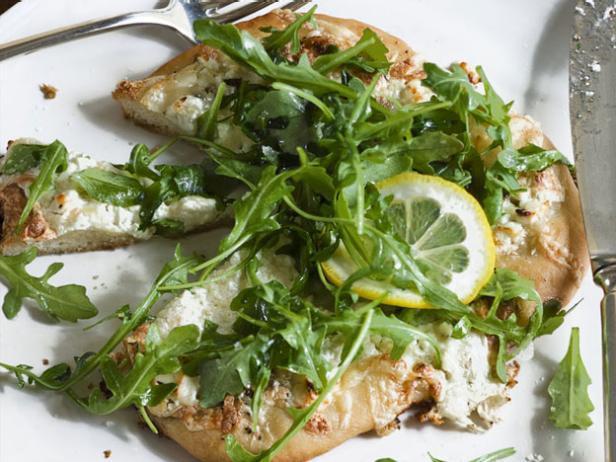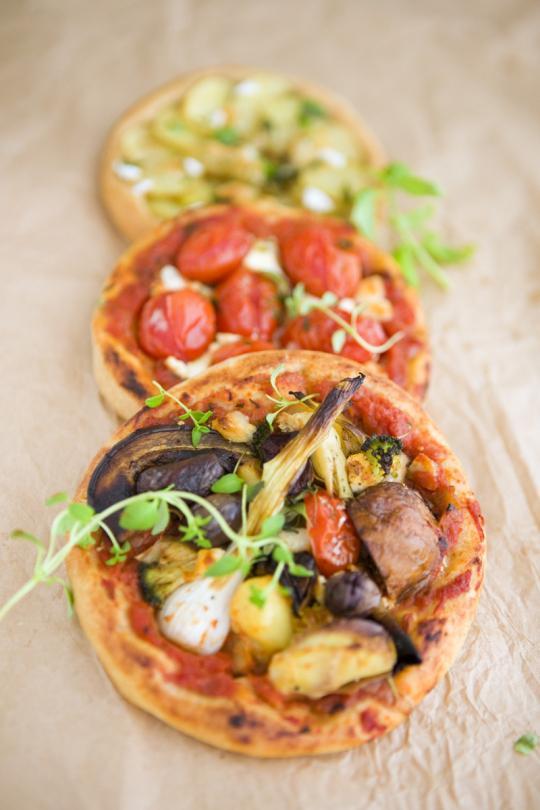The first image is the image on the left, the second image is the image on the right. Considering the images on both sides, is "There are whole tomatoes." valid? Answer yes or no. No. The first image is the image on the left, the second image is the image on the right. Considering the images on both sides, is "There are multiple pizzas in one of the images and only one pizza in the other image." valid? Answer yes or no. Yes. 